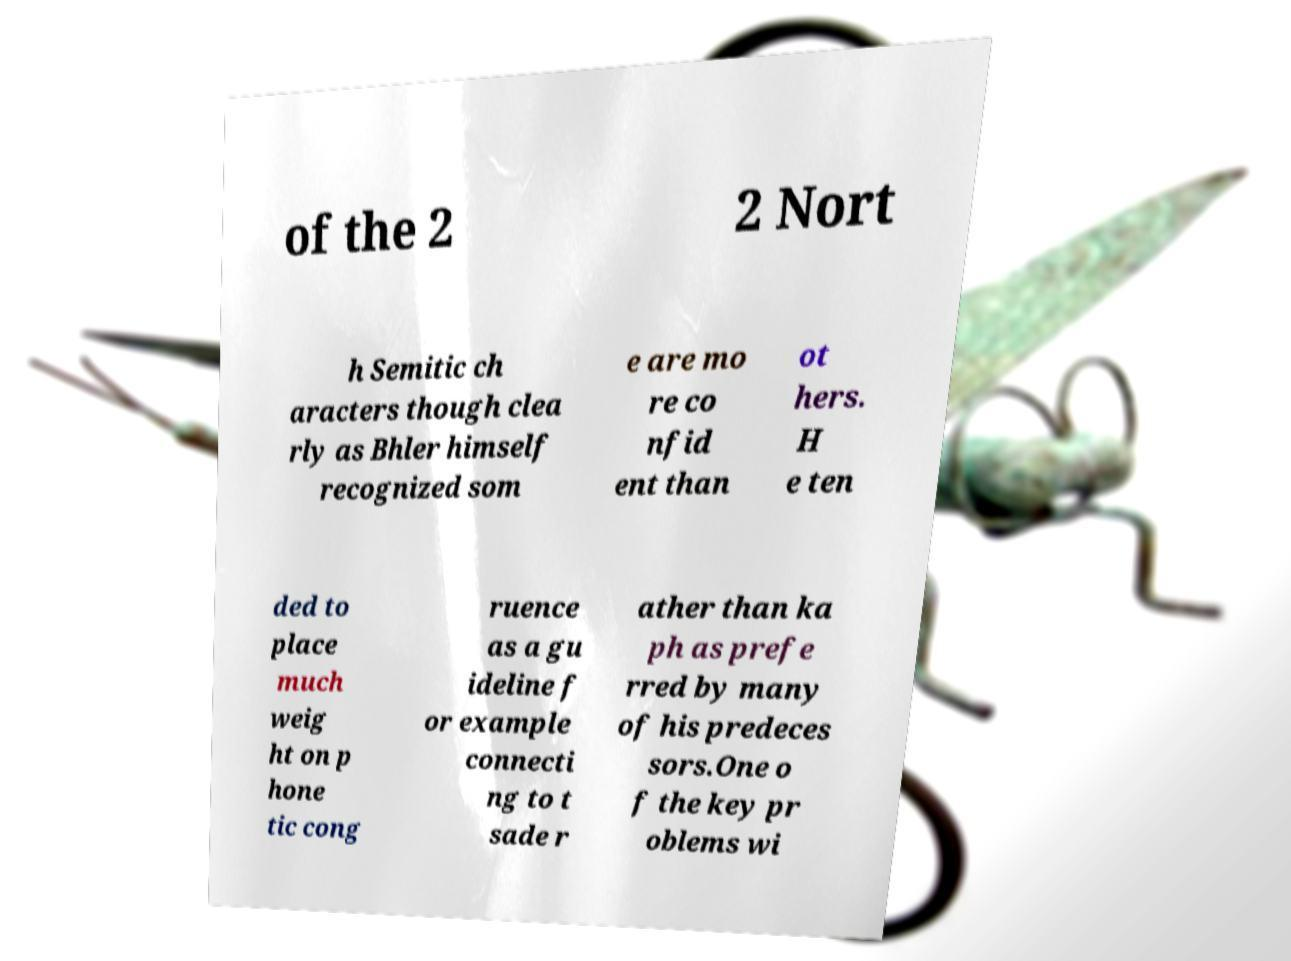Can you accurately transcribe the text from the provided image for me? of the 2 2 Nort h Semitic ch aracters though clea rly as Bhler himself recognized som e are mo re co nfid ent than ot hers. H e ten ded to place much weig ht on p hone tic cong ruence as a gu ideline f or example connecti ng to t sade r ather than ka ph as prefe rred by many of his predeces sors.One o f the key pr oblems wi 